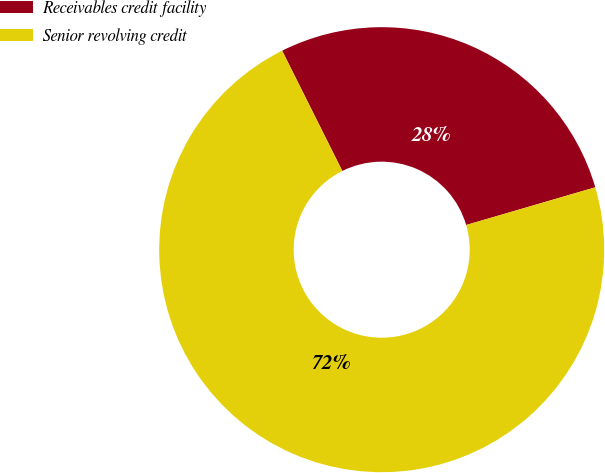<chart> <loc_0><loc_0><loc_500><loc_500><pie_chart><fcel>Receivables credit facility<fcel>Senior revolving credit<nl><fcel>27.86%<fcel>72.14%<nl></chart> 